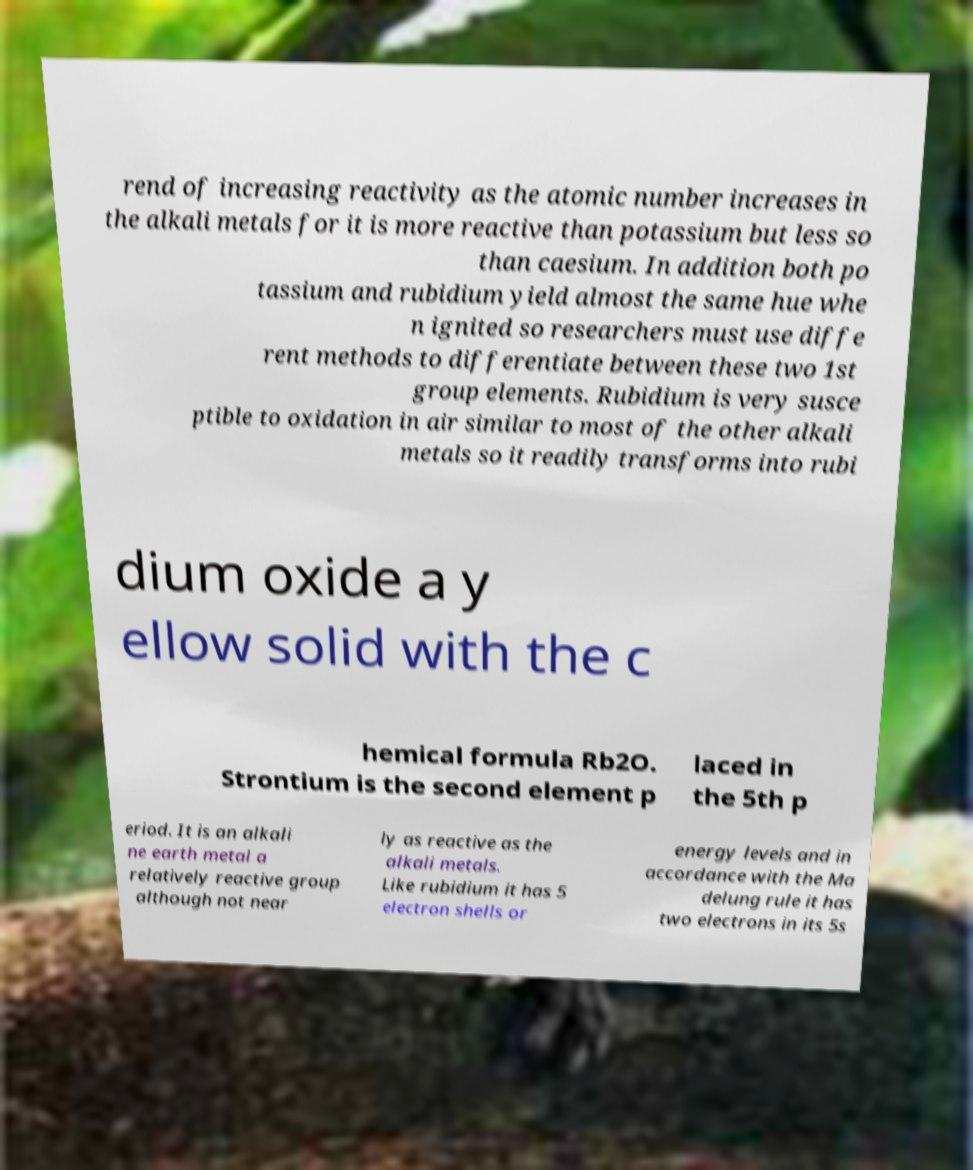What messages or text are displayed in this image? I need them in a readable, typed format. rend of increasing reactivity as the atomic number increases in the alkali metals for it is more reactive than potassium but less so than caesium. In addition both po tassium and rubidium yield almost the same hue whe n ignited so researchers must use diffe rent methods to differentiate between these two 1st group elements. Rubidium is very susce ptible to oxidation in air similar to most of the other alkali metals so it readily transforms into rubi dium oxide a y ellow solid with the c hemical formula Rb2O. Strontium is the second element p laced in the 5th p eriod. It is an alkali ne earth metal a relatively reactive group although not near ly as reactive as the alkali metals. Like rubidium it has 5 electron shells or energy levels and in accordance with the Ma delung rule it has two electrons in its 5s 